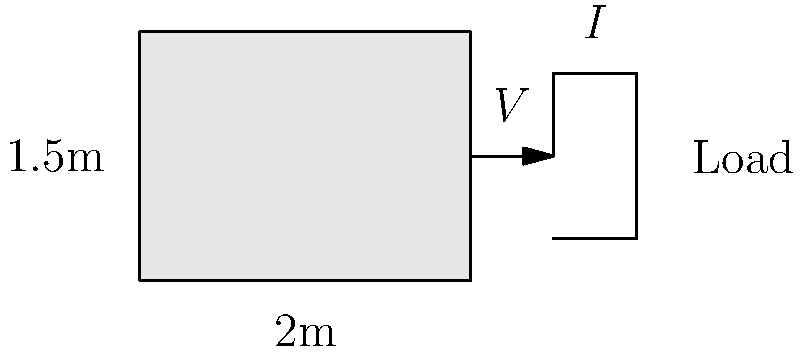A compact solar panel array measuring 2m by 1.5m is deployed in a crisis-affected area to provide emergency power. If the solar irradiance is 1000 W/m², the panel efficiency is 18%, and the output voltage is 24V, what is the approximate current output of the array? To solve this problem, we'll follow these steps:

1. Calculate the area of the solar panel array:
   Area = Length × Width = 2m × 1.5m = 3 m²

2. Calculate the total solar power incident on the panel:
   Incident Power = Solar Irradiance × Area
   Incident Power = 1000 W/m² × 3 m² = 3000 W

3. Calculate the power output of the panel considering its efficiency:
   Output Power = Incident Power × Efficiency
   Output Power = 3000 W × 0.18 = 540 W

4. Use the power equation to find the current:
   Power = Voltage × Current
   540 W = 24 V × Current

5. Solve for the current:
   Current = Power ÷ Voltage
   Current = 540 W ÷ 24 V = 22.5 A

Therefore, the approximate current output of the solar panel array is 22.5 A.
Answer: 22.5 A 